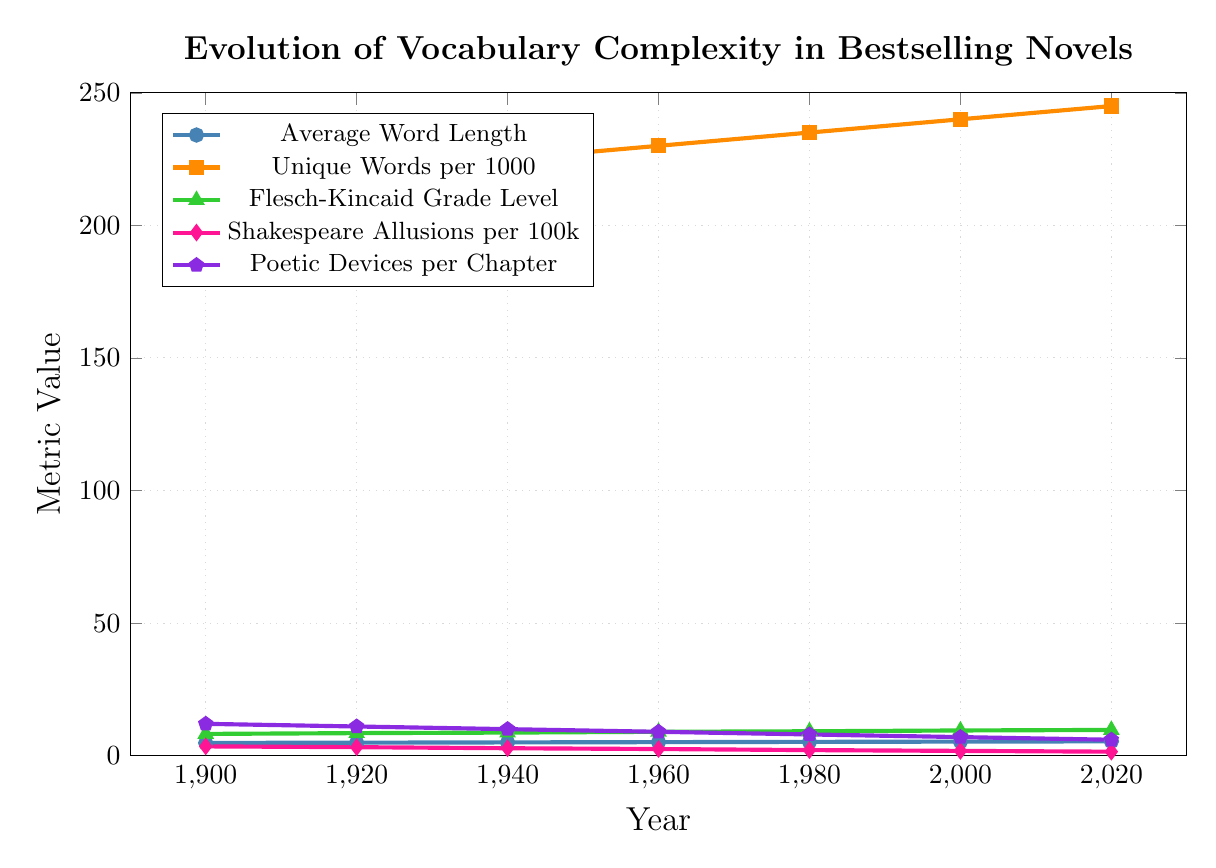What is the trend in average word length from 1900 to 2020? The data for average word length shows a steady increase from 4.8 in 1900 to 5.4 in 2020. This indicates a consistent rise over the years.
Answer: Steady increase Which metric shows a declining trend throughout the years? Shakespeare allusions per 100,000 show a continuous decline from 3.5 in 1900 to 1.5 in 2020.
Answer: Shakespeare allusions per 100k In which year did the unique words per 1000 reach 240? From the plot, unique words per 1000 reached 240 in the year 2000.
Answer: 2000 Compare the change in Flesch-Kincaid Grade Level between 1920 and 1960. In 1920, the Flesch-Kincaid Grade Level was 8.5. By 1960, it had increased to 9.0, indicating a rise of 0.5 over the 40-year period.
Answer: Increased by 0.5 How many poetic devices per chapter were used on average in 1980? In 1980, the number of poetic devices per chapter was 8.
Answer: 8 Which year had the highest number of unique words per 1000? 2020 saw the highest number of unique words per 1000 with a count of 245.
Answer: 2020 Between 1900 and 2000, which metric had the smallest overall change? The Shakespeare allusions per 100k show a change from 3.5 in 1900 to 1.8 in 2000, resulting in an overall decrease of 1.7. Comparing other metrics, this is the smallest change.
Answer: Shakespeare allusions per 100k What is the average Flesch-Kincaid Grade Level of novels over the entire period? The Flesch-Kincaid Grade Levels from 1900 to 2020 are 8.2, 8.5, 8.7, 9.0, 9.2, 9.5, and 9.7. Summing these values gives 62.8, and dividing by 7 (the number of data points) results in an average of 8.97.
Answer: 8.97 How does the trend in poetic devices per chapter compare to that of average word length? Poetic devices per chapter trend downward from 12 in 1900 to 6 in 2020, whereas average word length trends upward from 4.8 to 5.4 over the same period. The trends are inversely related.
Answer: Inversely related 